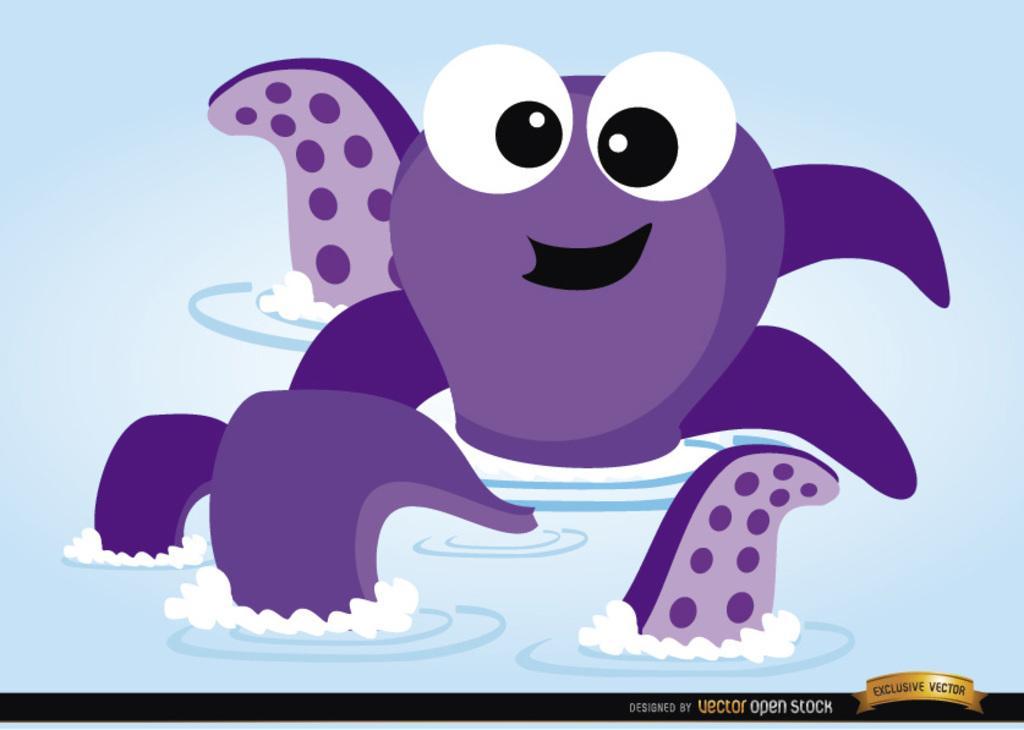Please provide a concise description of this image. In this picture there are vector open stock animals in the image, on the water. 